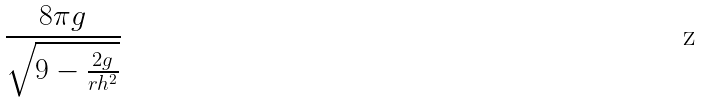<formula> <loc_0><loc_0><loc_500><loc_500>\frac { 8 \pi g } { \sqrt { 9 - \frac { 2 g } { r h ^ { 2 } } } }</formula> 